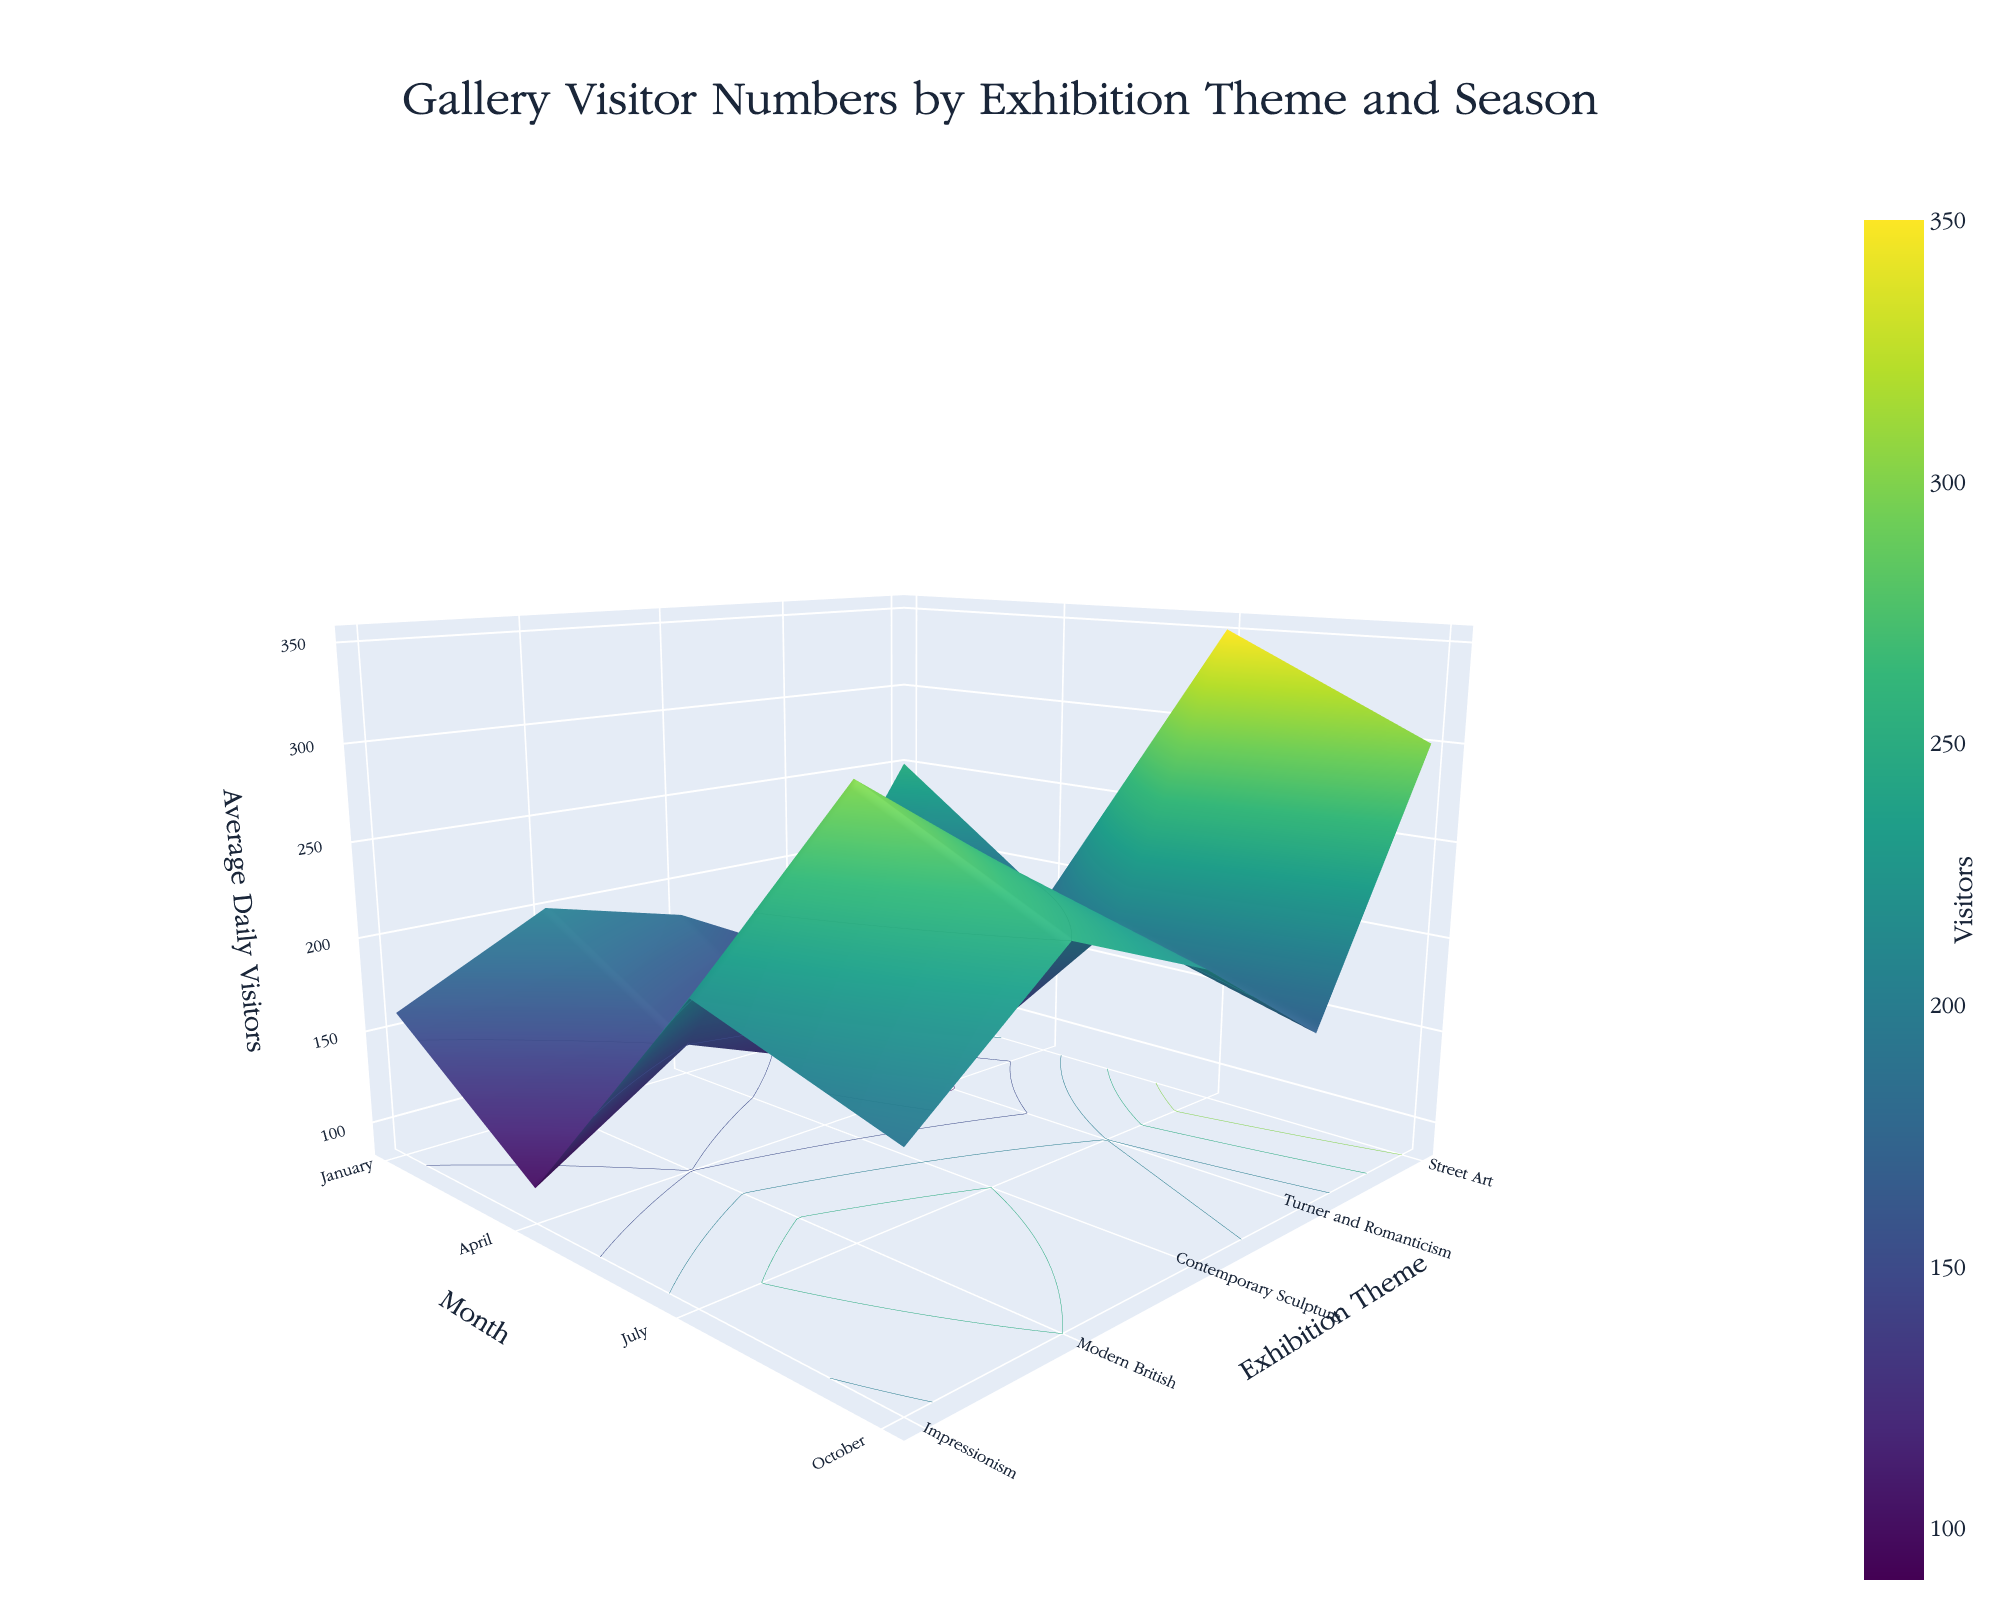What's the title of the figure? The title is displayed at the top of the figure, centred and in a larger font size than the rest of the text.
Answer: Gallery Visitor Numbers by Exhibition Theme and Season What are the axes representing in the 3D surface plot? The x-axis, y-axis, and z-axis titles describe the data visualised. The x-axis represents the months, the y-axis represents the exhibition themes, and the z-axis represents the average daily visitors.
Answer: The x-axis represents the Month, the y-axis represents the Exhibition Theme, and the z-axis represents the Average Daily Visitors What exhibition theme has the highest average daily visitors and in which month? Looking at the highest peak in the z-axis (Average Daily Visitors) reveals which exhibition has the highest number. Cross-referencing this with the x-axis (Month) and y-axis (Exhibition Theme) labels provides the specific context.
Answer: Turner and Romanticism in July Which month had the least visitors on average across all themes? By observing the z-values and the color gradients for each month, we can identify the month with the lowest average visitors by noting which month consistently appears lower on the z-scale across different themes.
Answer: January How does the average number of visitors for the Modern British exhibition in October compare to that of the Contemporary Sculpture exhibition in the same month? Locate the z-values for both "Modern British" and "Contemporary Sculpture" in October on the plot, and compare their heights.
Answer: Modern British has higher average visitors than Contemporary Sculpture in October What is the trend in visitor numbers for Impressionism from January to October? Observe the z-values for the "Impressionism" theme across the months from January to October. An increasing or decreasing trend can be identified by changes in the heights on the z-axis.
Answer: Increasing trend from January to July, then slightly decreases in October What is the difference in average daily visitors between Street Art in July and January? Find the z-values corresponding to "Street Art" for January and July. Subtract the value in January from the value in July.
Answer: 110 Which exhibition themes have a consistent increase in visitors from January to October? Examine the z-values for each theme from January through October and identify which themes show a progressively increasing z-value.
Answer: Turner and Romanticism Among all the themes, which one had the most variation in the number of visitors across different seasons? Identify the theme with the largest range by observing the overall spread of z-values (heights) from the highest to the lowest point.
Answer: Turner and Romanticism 